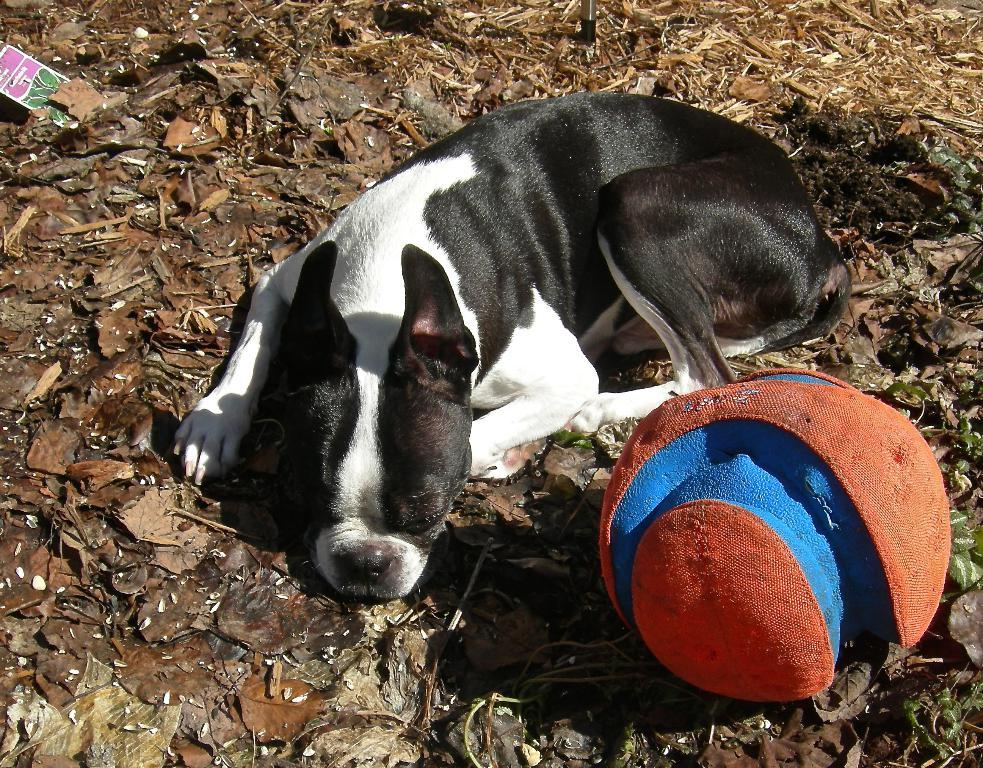What animal can be seen in the image? There is a dog in the image. What is the dog doing in the image? The dog is laying on the ground. What object is near the dog in the image? There is a ball in the image, and it is on the side of the dog. What is the color of the leaves on the ground? The provided facts do not mention the color of the leaves. What are the colors of the dog and the ball in the image? The dog is white and black in color, and the ball is blue and red in color. What does the caption on the image say about the dog's hands? There is no caption present in the image, and dogs do not have hands. 